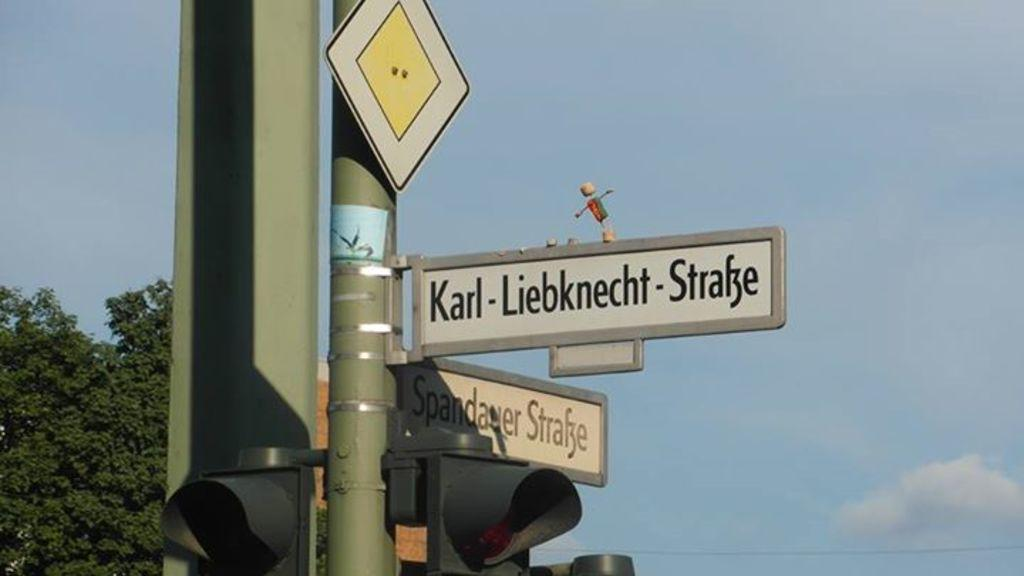What is the main object in the image? There is a traffic signal in the image. What can be seen in the background of the image? There are boards attached to a pole and trees with green color in the background. How would you describe the sky in the image? The sky has blue and white colors in the image. What type of mouth can be seen on the traffic signal in the image? There is no mouth present on the traffic signal in the image. 